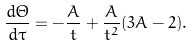Convert formula to latex. <formula><loc_0><loc_0><loc_500><loc_500>\frac { d \Theta } { d \tau } = - \frac { A } { t } + \frac { A } { t ^ { 2 } } ( 3 A - 2 ) .</formula> 